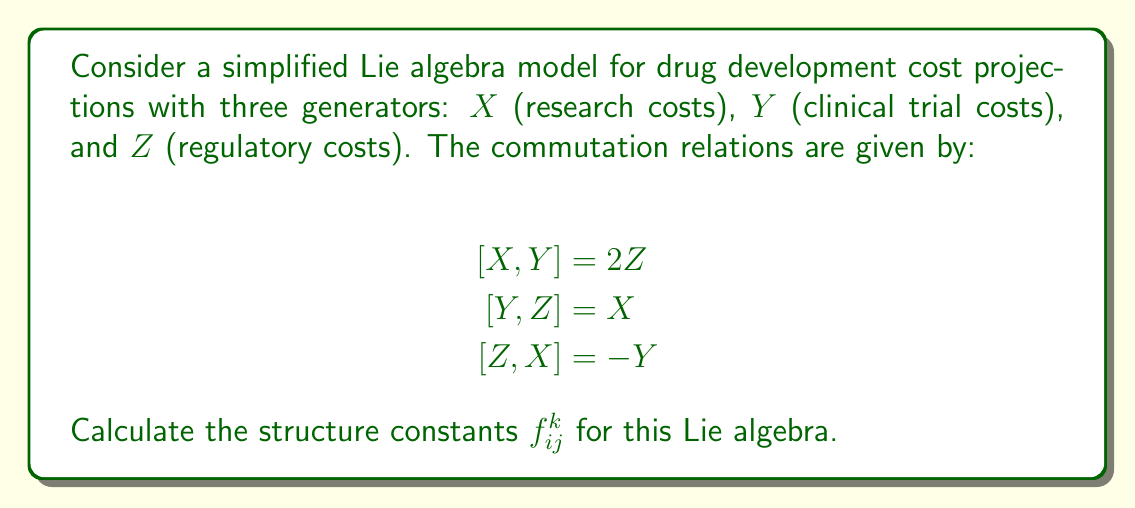Can you solve this math problem? To calculate the structure constants, we need to express the commutation relations in terms of the structure constants using the general formula:

$$[e_i, e_j] = \sum_k f_{ij}^k e_k$$

Where $e_i$, $e_j$, and $e_k$ are basis elements of the Lie algebra, and $f_{ij}^k$ are the structure constants.

In our case, we have:

1. $[X,Y] = 2Z$
   This implies $f_{12}^3 = 2$ and $f_{21}^3 = -2$ (since $f_{ij}^k = -f_{ji}^k$)

2. $[Y,Z] = X$
   This implies $f_{23}^1 = 1$ and $f_{32}^1 = -1$

3. $[Z,X] = -Y$
   This implies $f_{31}^2 = -1$ and $f_{13}^2 = 1$

All other structure constants are zero.

We can represent the non-zero structure constants in a 3x3x3 array:

$$f_{ij}^k = \begin{bmatrix}
0 & 2 & -1 \\
-2 & 0 & 1 \\
1 & -1 & 0
\end{bmatrix}$$

Where the first index $i$ represents the row, the second index $j$ represents the column, and the third index $k$ represents which of the three 3x3 matrices we're looking at (from front to back).
Answer: The non-zero structure constants are:

$f_{12}^3 = 2$, $f_{21}^3 = -2$
$f_{23}^1 = 1$, $f_{32}^1 = -1$
$f_{31}^2 = -1$, $f_{13}^2 = 1$

All other $f_{ij}^k = 0$ 